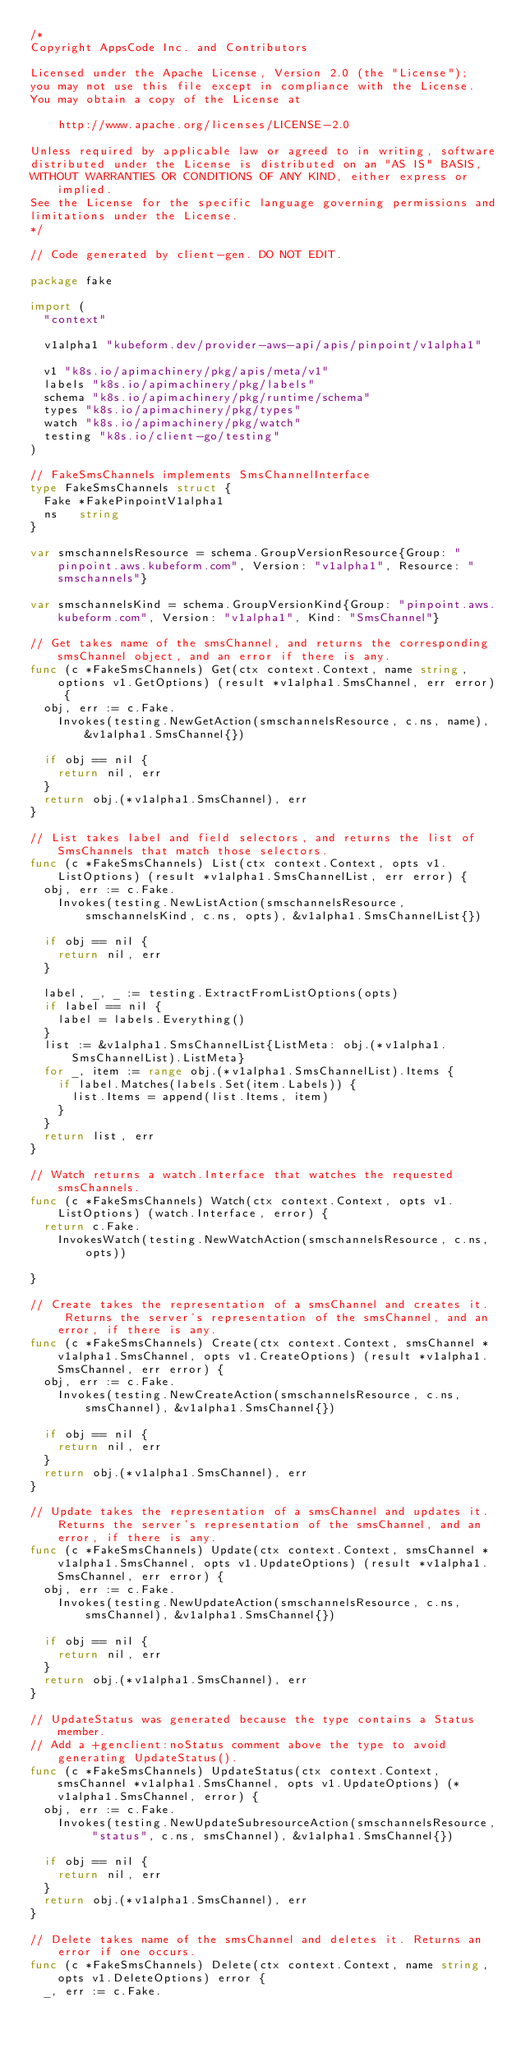Convert code to text. <code><loc_0><loc_0><loc_500><loc_500><_Go_>/*
Copyright AppsCode Inc. and Contributors

Licensed under the Apache License, Version 2.0 (the "License");
you may not use this file except in compliance with the License.
You may obtain a copy of the License at

    http://www.apache.org/licenses/LICENSE-2.0

Unless required by applicable law or agreed to in writing, software
distributed under the License is distributed on an "AS IS" BASIS,
WITHOUT WARRANTIES OR CONDITIONS OF ANY KIND, either express or implied.
See the License for the specific language governing permissions and
limitations under the License.
*/

// Code generated by client-gen. DO NOT EDIT.

package fake

import (
	"context"

	v1alpha1 "kubeform.dev/provider-aws-api/apis/pinpoint/v1alpha1"

	v1 "k8s.io/apimachinery/pkg/apis/meta/v1"
	labels "k8s.io/apimachinery/pkg/labels"
	schema "k8s.io/apimachinery/pkg/runtime/schema"
	types "k8s.io/apimachinery/pkg/types"
	watch "k8s.io/apimachinery/pkg/watch"
	testing "k8s.io/client-go/testing"
)

// FakeSmsChannels implements SmsChannelInterface
type FakeSmsChannels struct {
	Fake *FakePinpointV1alpha1
	ns   string
}

var smschannelsResource = schema.GroupVersionResource{Group: "pinpoint.aws.kubeform.com", Version: "v1alpha1", Resource: "smschannels"}

var smschannelsKind = schema.GroupVersionKind{Group: "pinpoint.aws.kubeform.com", Version: "v1alpha1", Kind: "SmsChannel"}

// Get takes name of the smsChannel, and returns the corresponding smsChannel object, and an error if there is any.
func (c *FakeSmsChannels) Get(ctx context.Context, name string, options v1.GetOptions) (result *v1alpha1.SmsChannel, err error) {
	obj, err := c.Fake.
		Invokes(testing.NewGetAction(smschannelsResource, c.ns, name), &v1alpha1.SmsChannel{})

	if obj == nil {
		return nil, err
	}
	return obj.(*v1alpha1.SmsChannel), err
}

// List takes label and field selectors, and returns the list of SmsChannels that match those selectors.
func (c *FakeSmsChannels) List(ctx context.Context, opts v1.ListOptions) (result *v1alpha1.SmsChannelList, err error) {
	obj, err := c.Fake.
		Invokes(testing.NewListAction(smschannelsResource, smschannelsKind, c.ns, opts), &v1alpha1.SmsChannelList{})

	if obj == nil {
		return nil, err
	}

	label, _, _ := testing.ExtractFromListOptions(opts)
	if label == nil {
		label = labels.Everything()
	}
	list := &v1alpha1.SmsChannelList{ListMeta: obj.(*v1alpha1.SmsChannelList).ListMeta}
	for _, item := range obj.(*v1alpha1.SmsChannelList).Items {
		if label.Matches(labels.Set(item.Labels)) {
			list.Items = append(list.Items, item)
		}
	}
	return list, err
}

// Watch returns a watch.Interface that watches the requested smsChannels.
func (c *FakeSmsChannels) Watch(ctx context.Context, opts v1.ListOptions) (watch.Interface, error) {
	return c.Fake.
		InvokesWatch(testing.NewWatchAction(smschannelsResource, c.ns, opts))

}

// Create takes the representation of a smsChannel and creates it.  Returns the server's representation of the smsChannel, and an error, if there is any.
func (c *FakeSmsChannels) Create(ctx context.Context, smsChannel *v1alpha1.SmsChannel, opts v1.CreateOptions) (result *v1alpha1.SmsChannel, err error) {
	obj, err := c.Fake.
		Invokes(testing.NewCreateAction(smschannelsResource, c.ns, smsChannel), &v1alpha1.SmsChannel{})

	if obj == nil {
		return nil, err
	}
	return obj.(*v1alpha1.SmsChannel), err
}

// Update takes the representation of a smsChannel and updates it. Returns the server's representation of the smsChannel, and an error, if there is any.
func (c *FakeSmsChannels) Update(ctx context.Context, smsChannel *v1alpha1.SmsChannel, opts v1.UpdateOptions) (result *v1alpha1.SmsChannel, err error) {
	obj, err := c.Fake.
		Invokes(testing.NewUpdateAction(smschannelsResource, c.ns, smsChannel), &v1alpha1.SmsChannel{})

	if obj == nil {
		return nil, err
	}
	return obj.(*v1alpha1.SmsChannel), err
}

// UpdateStatus was generated because the type contains a Status member.
// Add a +genclient:noStatus comment above the type to avoid generating UpdateStatus().
func (c *FakeSmsChannels) UpdateStatus(ctx context.Context, smsChannel *v1alpha1.SmsChannel, opts v1.UpdateOptions) (*v1alpha1.SmsChannel, error) {
	obj, err := c.Fake.
		Invokes(testing.NewUpdateSubresourceAction(smschannelsResource, "status", c.ns, smsChannel), &v1alpha1.SmsChannel{})

	if obj == nil {
		return nil, err
	}
	return obj.(*v1alpha1.SmsChannel), err
}

// Delete takes name of the smsChannel and deletes it. Returns an error if one occurs.
func (c *FakeSmsChannels) Delete(ctx context.Context, name string, opts v1.DeleteOptions) error {
	_, err := c.Fake.</code> 